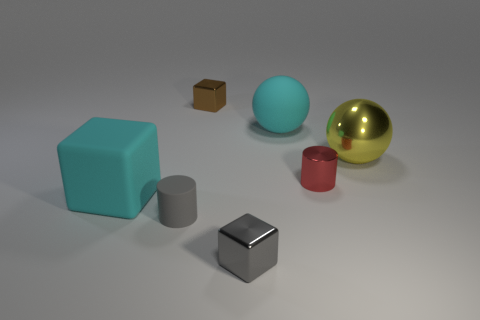Is the small red object the same shape as the tiny matte thing?
Offer a very short reply. Yes. There is a cyan matte thing left of the cyan matte ball; what number of small red shiny cylinders are in front of it?
Make the answer very short. 0. There is a tiny red object that is the same material as the big yellow thing; what shape is it?
Offer a terse response. Cylinder. What number of blue objects are rubber balls or small matte objects?
Keep it short and to the point. 0. There is a small cylinder that is in front of the big cyan matte object that is on the left side of the tiny gray metallic thing; is there a brown shiny block that is in front of it?
Make the answer very short. No. Is the number of tiny gray cylinders less than the number of small metal cubes?
Your response must be concise. Yes. Does the large cyan thing in front of the big rubber ball have the same shape as the big yellow object?
Make the answer very short. No. Is there a cyan cube?
Ensure brevity in your answer.  Yes. What color is the rubber thing that is right of the rubber thing that is in front of the large cyan object that is to the left of the tiny matte cylinder?
Offer a very short reply. Cyan. Are there an equal number of yellow things that are behind the large yellow thing and metallic spheres that are left of the tiny gray matte cylinder?
Ensure brevity in your answer.  Yes. 